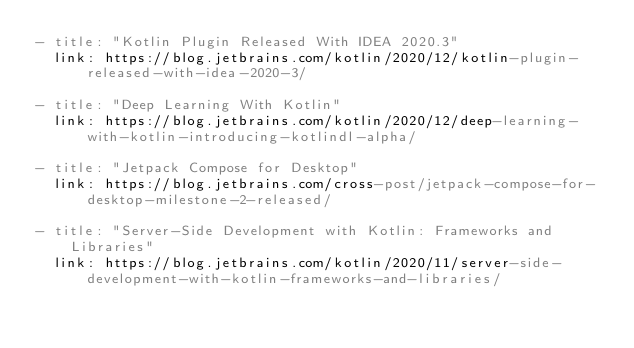Convert code to text. <code><loc_0><loc_0><loc_500><loc_500><_YAML_>- title: "Kotlin Plugin Released With IDEA 2020.3"
  link: https://blog.jetbrains.com/kotlin/2020/12/kotlin-plugin-released-with-idea-2020-3/

- title: "Deep Learning With Kotlin"
  link: https://blog.jetbrains.com/kotlin/2020/12/deep-learning-with-kotlin-introducing-kotlindl-alpha/

- title: "Jetpack Compose for Desktop"
  link: https://blog.jetbrains.com/cross-post/jetpack-compose-for-desktop-milestone-2-released/

- title: "Server-Side Development with Kotlin: Frameworks and Libraries"
  link: https://blog.jetbrains.com/kotlin/2020/11/server-side-development-with-kotlin-frameworks-and-libraries/</code> 